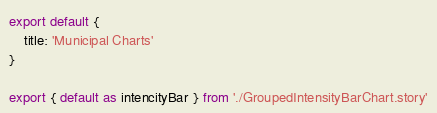Convert code to text. <code><loc_0><loc_0><loc_500><loc_500><_JavaScript_>
export default {
    title: 'Municipal Charts'
}

export { default as intencityBar } from './GroupedIntensityBarChart.story'</code> 